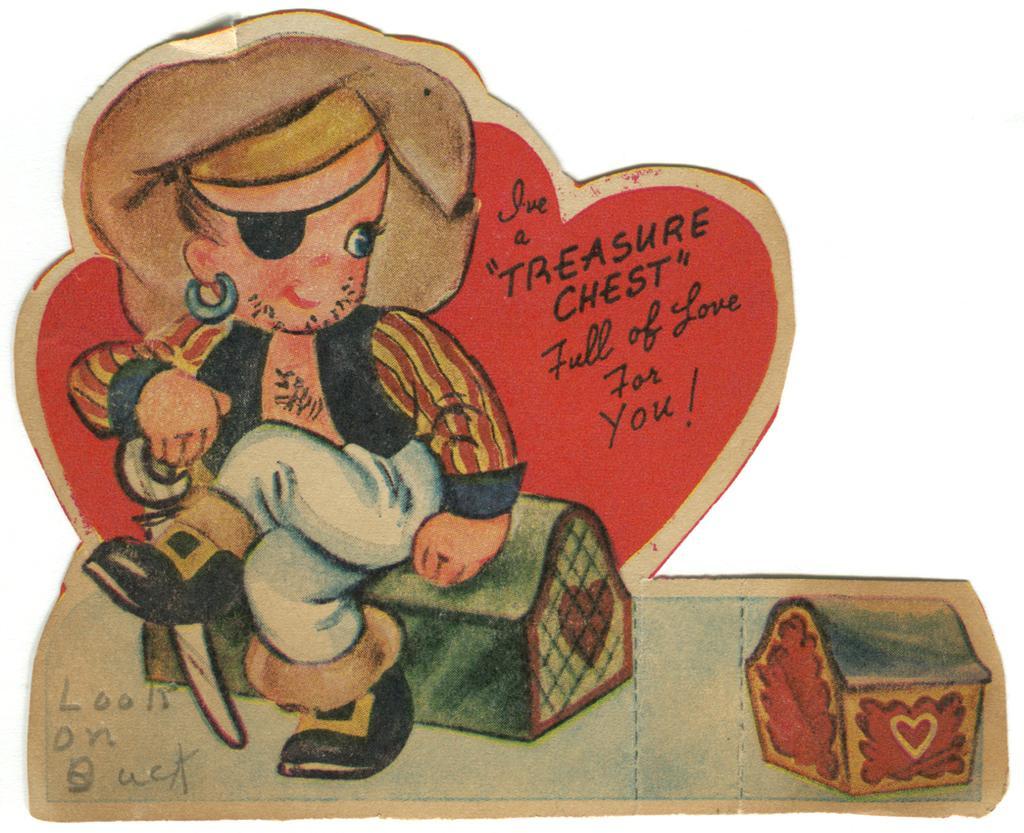Describe this image in one or two sentences. This is an animated image, in this image there is a girl sitting on a box, beside that there is another box and there is some text on that image. 